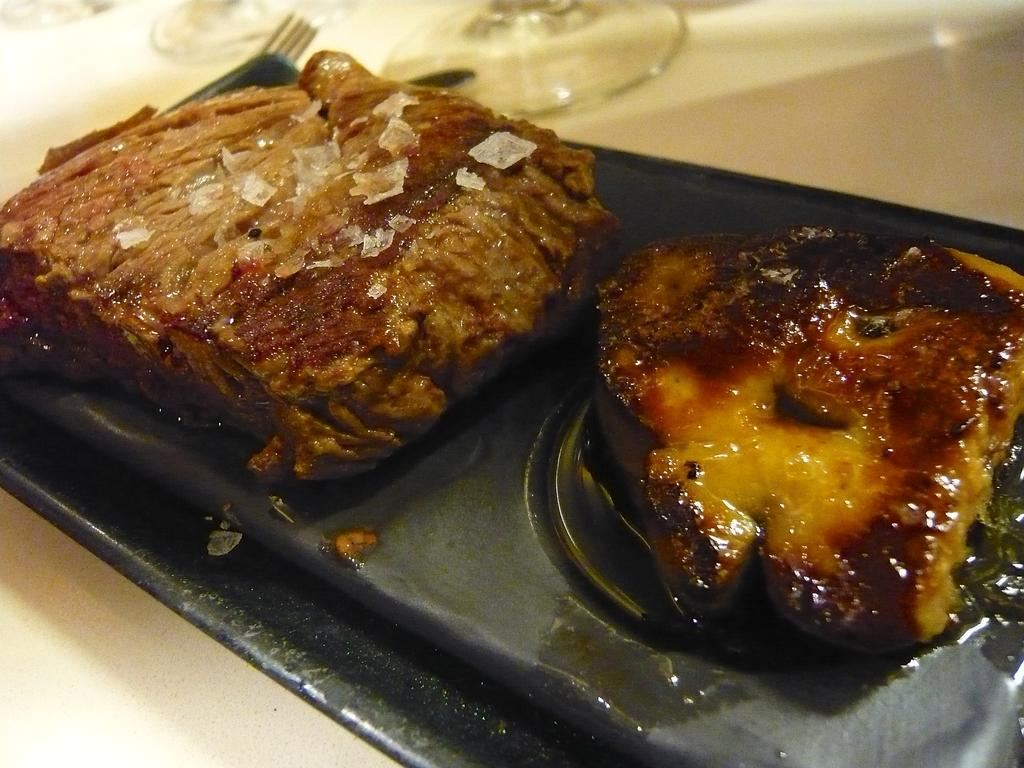What is on the tray in the image? There are food items on a tray in the image. What utensils are visible in the image? There is a fork and a knife in the image. What can be seen at the bottom of the glasses in the image? The bottom parts of glasses are visible in the image. What color is the surface that the tray is placed on? The surface is white in the image. Can you see any corn growing on the seashore in the image? There is no seashore or corn present in the image. Are there any giants visible in the image? There are no giants present in the image. 